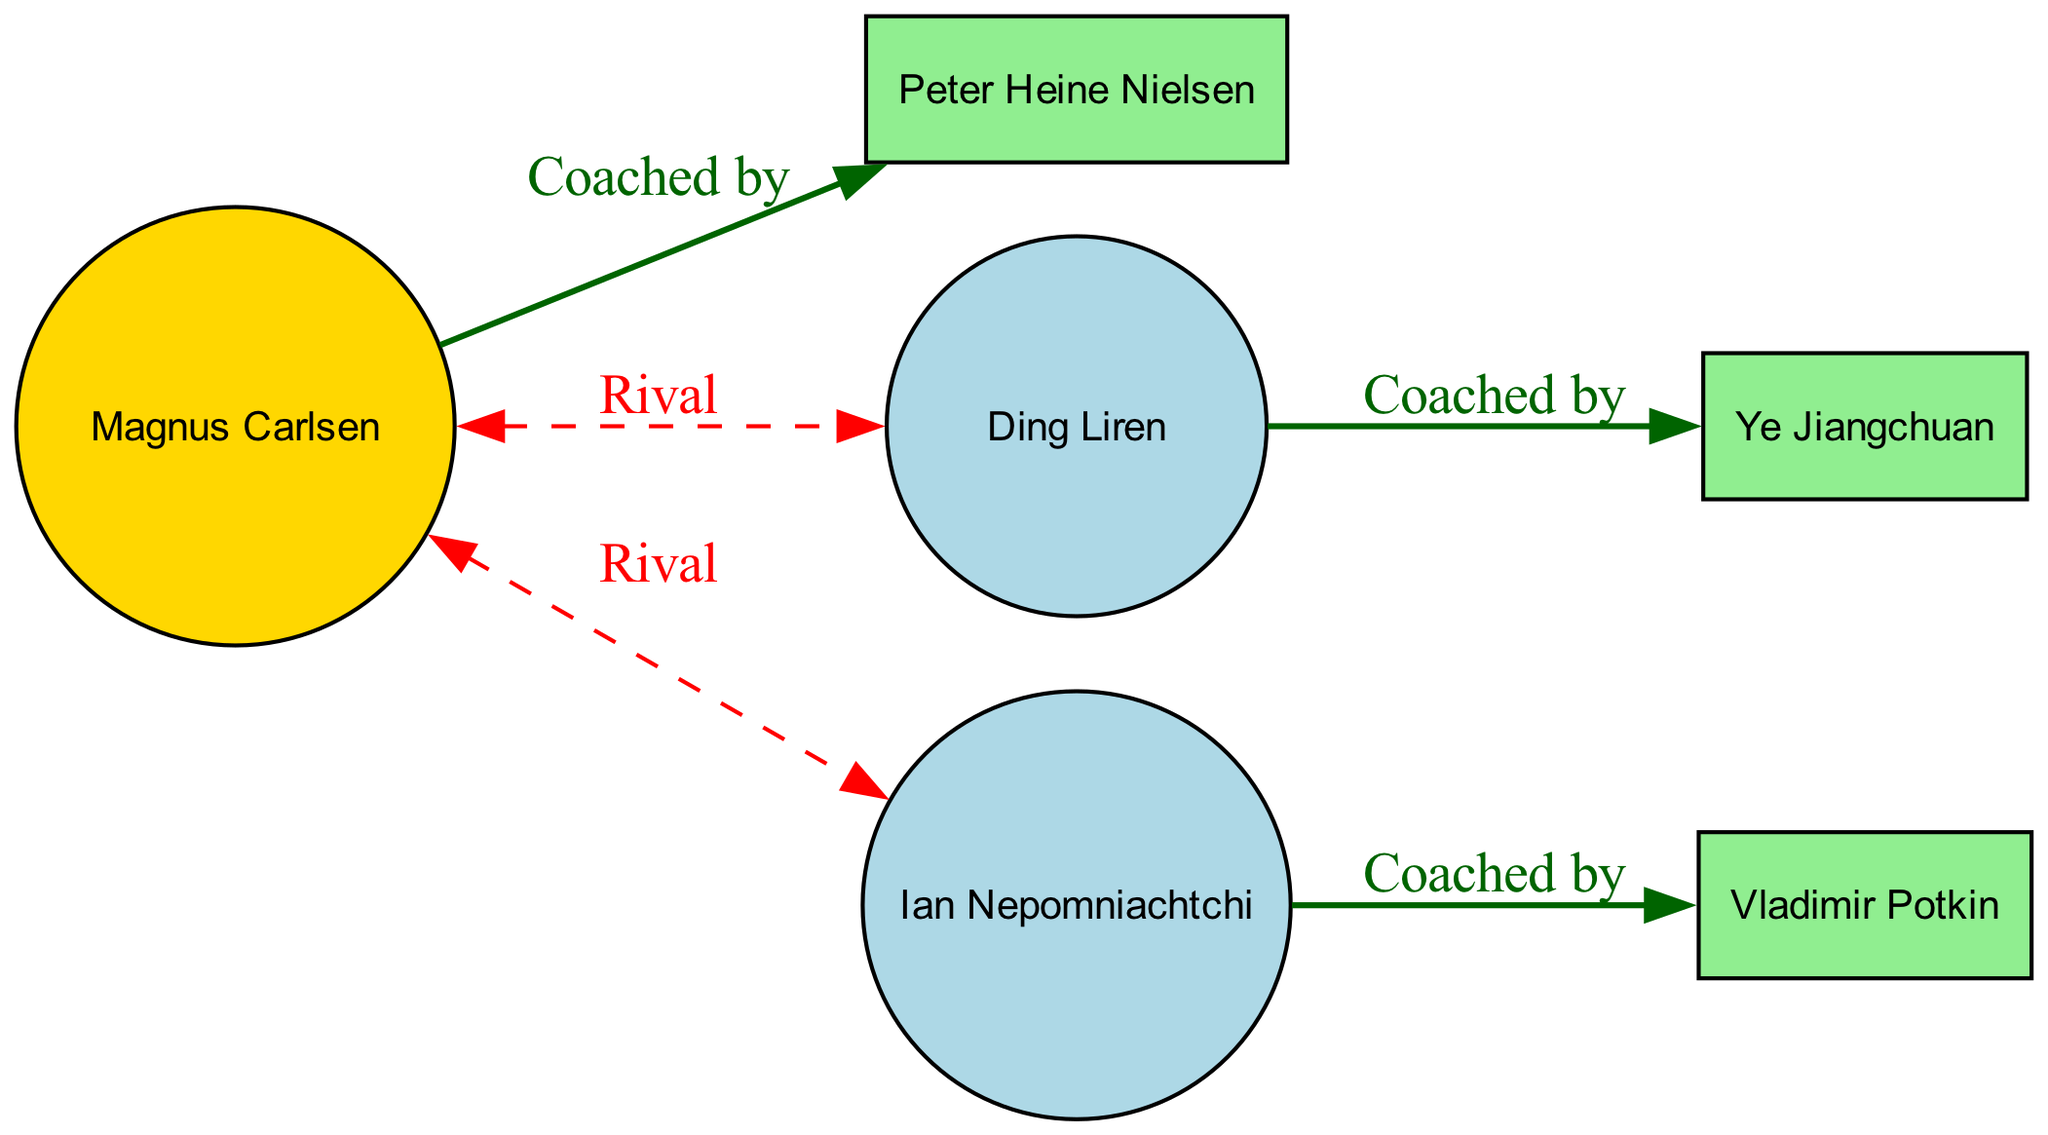What is the total number of nodes in the diagram? To find the total number of nodes, we count all distinct entities shown in the diagram. The data provides 6 nodes: Magnus Carlsen, Peter Heine Nielsen, Ding Liren, Ye Jiangchuan, Ian Nepomniachtchi, and Vladimir Potkin.
Answer: 6 Who is coached by Peter Heine Nielsen? The edge connecting Magnus Carlsen and Peter Heine Nielsen with the relationship "Coached by" indicates that Magnus Carlsen is the player being coached.
Answer: Magnus Carlsen Which player is a rival of Ian Nepomniachtchi? Looking at the relationships, we find that Ian Nepomniachtchi does not have a direct rivalry depicted in the diagram. Instead, we check for rival connections and see that Magnus Carlsen is connected as a rival to both Ding Liren and Ian Nepomniachtchi, but the question asks specifically for Ian. Therefore, there is no such direct rival shown for Ian.
Answer: None How many coaches are represented in the diagram? We identify all the nodes categorized as "Coach." In this diagram, there are three coaches: Peter Heine Nielsen, Ye Jiangchuan, and Vladimir Potkin.
Answer: 3 What color represents the World Champion in the diagram? In the diagram, the World Champion, Magnus Carlsen, is represented in gold color, as specified in the node style rules defined in the code.
Answer: Gold Which two players have a rivalry relationship marked in the diagram? The relationships between players are analyzed, focusing on the edges labeled as "Rival." The edges indicate that Magnus Carlsen has rivalry relationships with both Ding Liren and Ian Nepomniachtchi. Therefore, the answer will combine both players connected to Magnus as rivals.
Answer: Ding Liren, Ian Nepomniachtchi What is the relationship type between Ding Liren and Ye Jiangchuan? The edge connecting Ding Liren and Ye Jiangchuan indicates that Ye Jiangchuan is the coach of Ding Liren. The relationship is labeled as "Coached by."
Answer: Coached by Which type of node does Vladimir Potkin represent? According to the data, Vladimir Potkin is classified as a "Coach," which can be identified by checking the type attribute of the node associated with him.
Answer: Coach Which node does not have any rival relationships? Examining the connected edges, we see that the only player without direct rival relationships is Ding Liren, as he does not connect to any other node with a "Rival" label.
Answer: Ding Liren 